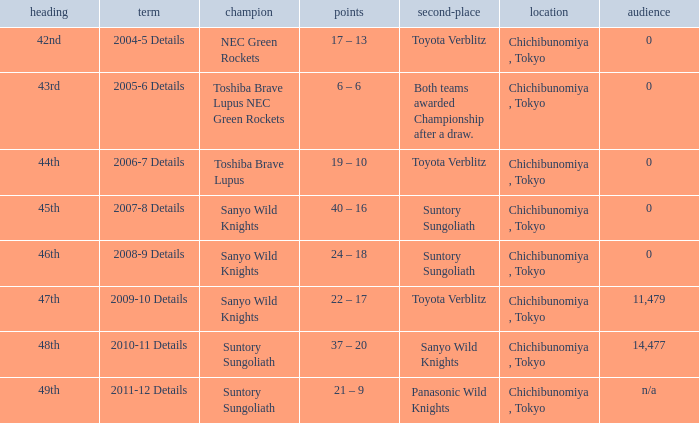What is the Title when the winner was suntory sungoliath, and a Season of 2011-12 details? 49th. 